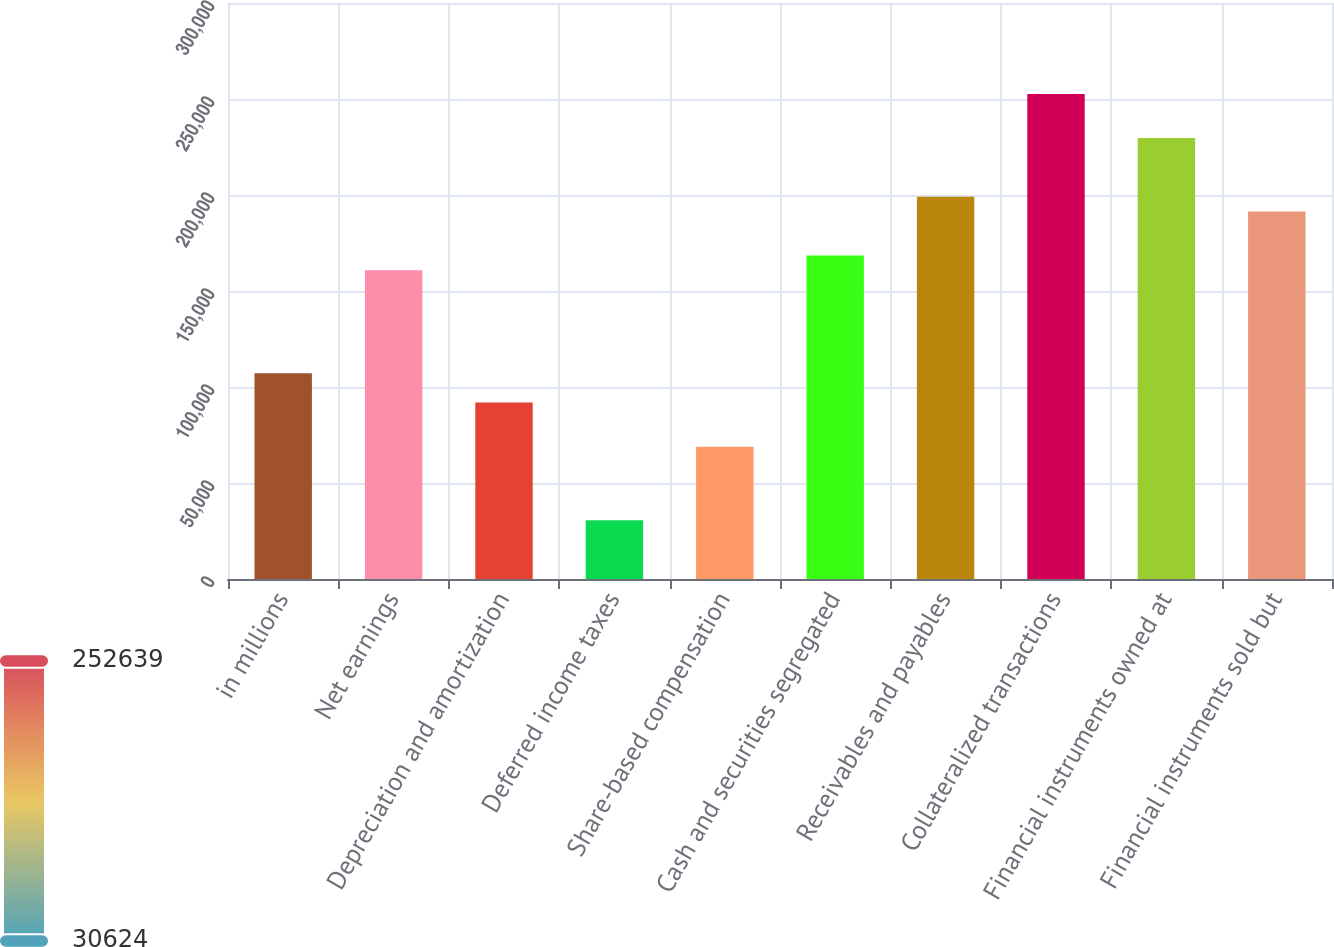Convert chart to OTSL. <chart><loc_0><loc_0><loc_500><loc_500><bar_chart><fcel>in millions<fcel>Net earnings<fcel>Depreciation and amortization<fcel>Deferred income taxes<fcel>Share-based compensation<fcel>Cash and securities segregated<fcel>Receivables and payables<fcel>Collateralized transactions<fcel>Financial instruments owned at<fcel>Financial instruments sold but<nl><fcel>107181<fcel>160771<fcel>91869.4<fcel>30623.8<fcel>68902.3<fcel>168426<fcel>199049<fcel>252639<fcel>229672<fcel>191394<nl></chart> 